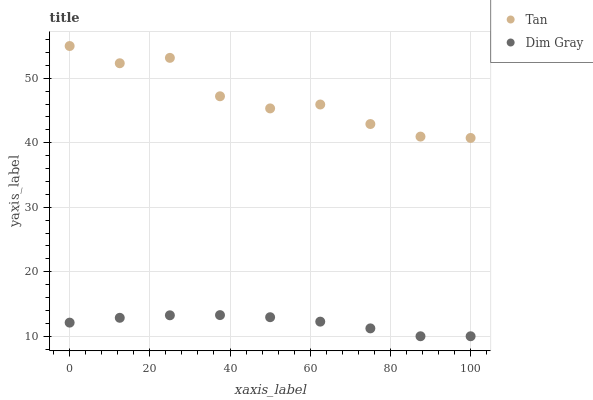Does Dim Gray have the minimum area under the curve?
Answer yes or no. Yes. Does Tan have the maximum area under the curve?
Answer yes or no. Yes. Does Dim Gray have the maximum area under the curve?
Answer yes or no. No. Is Dim Gray the smoothest?
Answer yes or no. Yes. Is Tan the roughest?
Answer yes or no. Yes. Is Dim Gray the roughest?
Answer yes or no. No. Does Dim Gray have the lowest value?
Answer yes or no. Yes. Does Tan have the highest value?
Answer yes or no. Yes. Does Dim Gray have the highest value?
Answer yes or no. No. Is Dim Gray less than Tan?
Answer yes or no. Yes. Is Tan greater than Dim Gray?
Answer yes or no. Yes. Does Dim Gray intersect Tan?
Answer yes or no. No. 